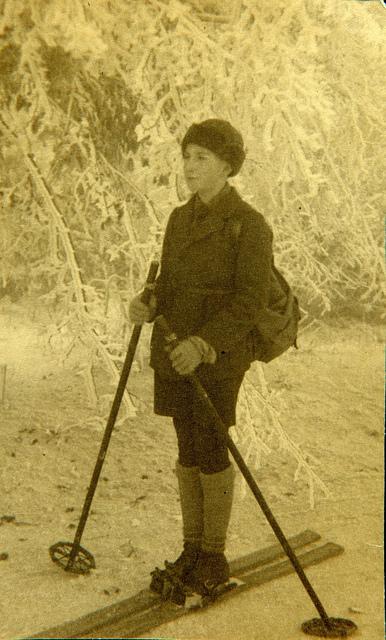Are the boots a solid color or patterned?
Keep it brief. Solid. Is this an old photo?
Short answer required. Yes. Is the person carrying a backpack?
Write a very short answer. Yes. 